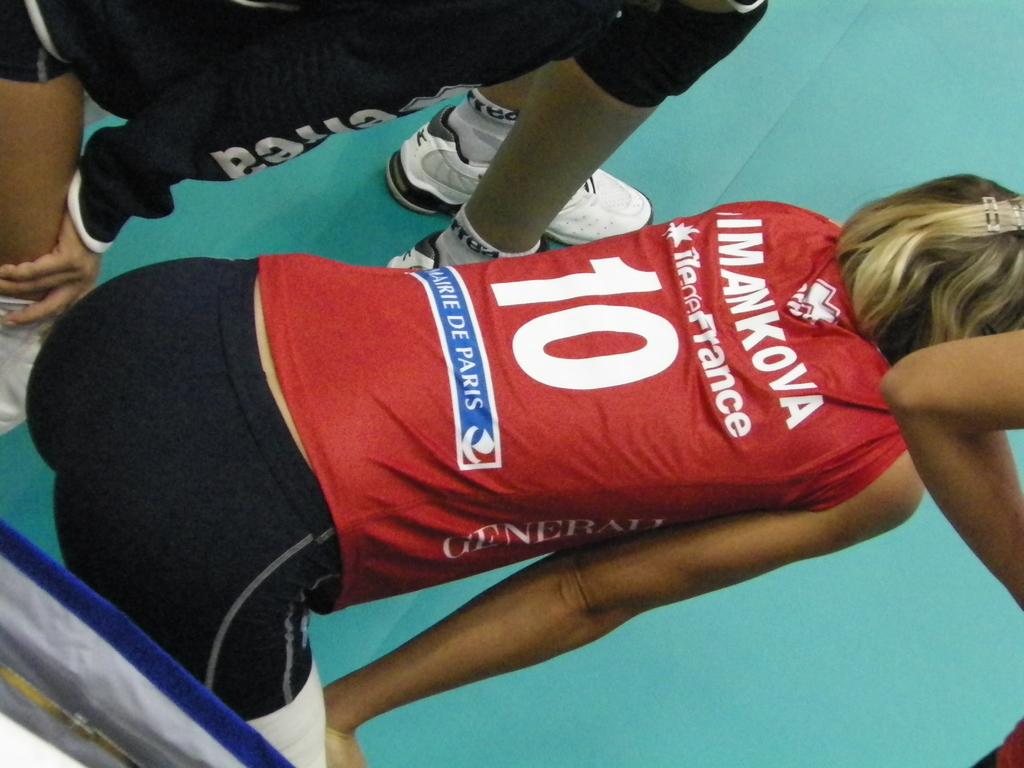What city is the last word printed on the back of this runners shirt?
Offer a terse response. Paris. What does it say above the number 10 on the red shirt?
Provide a succinct answer. Imankova. 